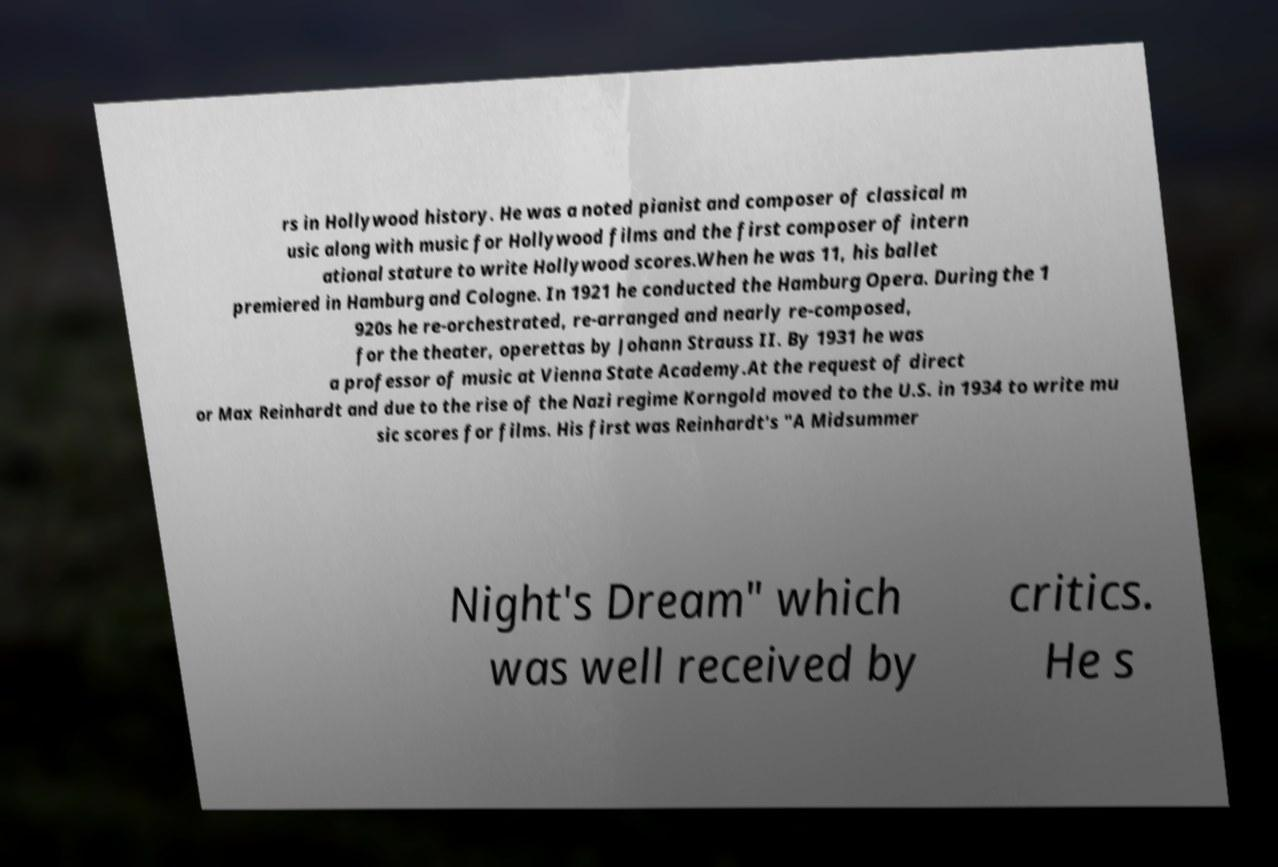Please identify and transcribe the text found in this image. rs in Hollywood history. He was a noted pianist and composer of classical m usic along with music for Hollywood films and the first composer of intern ational stature to write Hollywood scores.When he was 11, his ballet premiered in Hamburg and Cologne. In 1921 he conducted the Hamburg Opera. During the 1 920s he re-orchestrated, re-arranged and nearly re-composed, for the theater, operettas by Johann Strauss II. By 1931 he was a professor of music at Vienna State Academy.At the request of direct or Max Reinhardt and due to the rise of the Nazi regime Korngold moved to the U.S. in 1934 to write mu sic scores for films. His first was Reinhardt's "A Midsummer Night's Dream" which was well received by critics. He s 